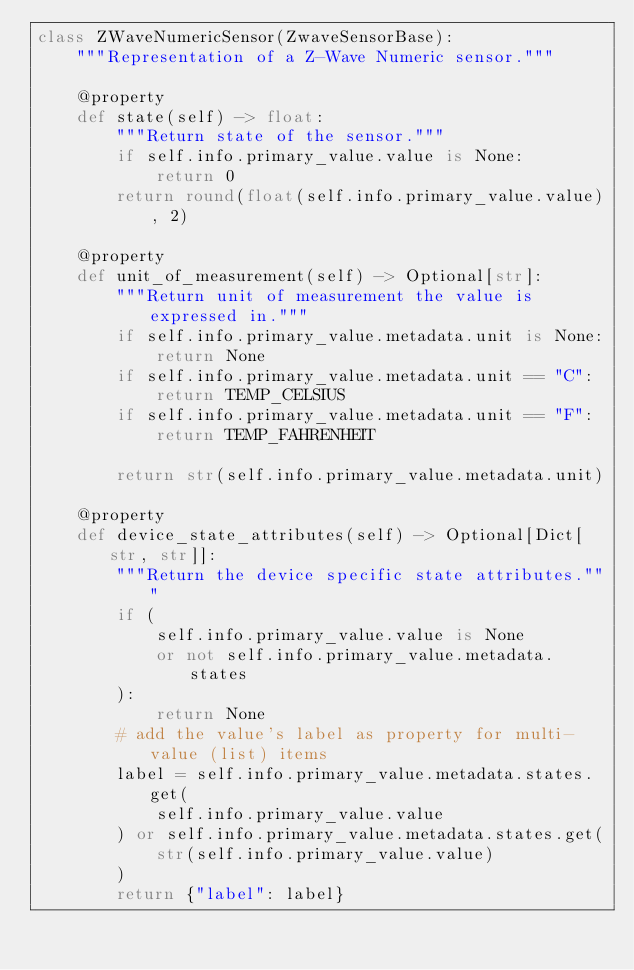<code> <loc_0><loc_0><loc_500><loc_500><_Python_>class ZWaveNumericSensor(ZwaveSensorBase):
    """Representation of a Z-Wave Numeric sensor."""

    @property
    def state(self) -> float:
        """Return state of the sensor."""
        if self.info.primary_value.value is None:
            return 0
        return round(float(self.info.primary_value.value), 2)

    @property
    def unit_of_measurement(self) -> Optional[str]:
        """Return unit of measurement the value is expressed in."""
        if self.info.primary_value.metadata.unit is None:
            return None
        if self.info.primary_value.metadata.unit == "C":
            return TEMP_CELSIUS
        if self.info.primary_value.metadata.unit == "F":
            return TEMP_FAHRENHEIT

        return str(self.info.primary_value.metadata.unit)

    @property
    def device_state_attributes(self) -> Optional[Dict[str, str]]:
        """Return the device specific state attributes."""
        if (
            self.info.primary_value.value is None
            or not self.info.primary_value.metadata.states
        ):
            return None
        # add the value's label as property for multi-value (list) items
        label = self.info.primary_value.metadata.states.get(
            self.info.primary_value.value
        ) or self.info.primary_value.metadata.states.get(
            str(self.info.primary_value.value)
        )
        return {"label": label}
</code> 